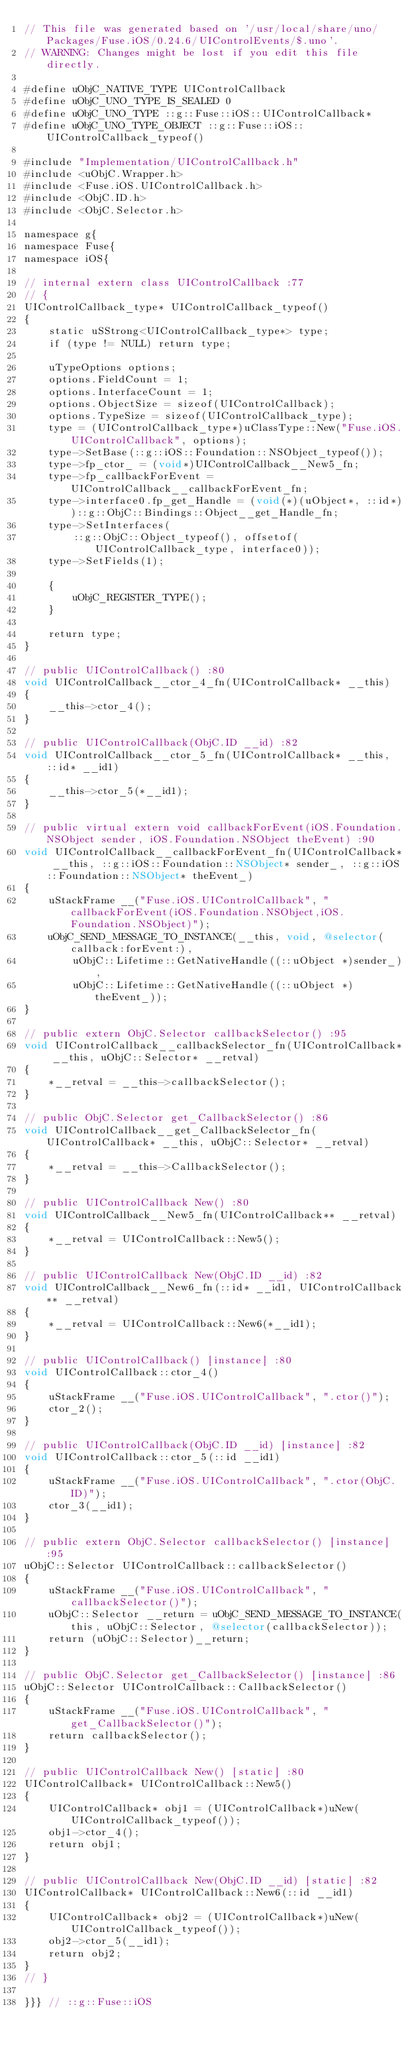<code> <loc_0><loc_0><loc_500><loc_500><_ObjectiveC_>// This file was generated based on '/usr/local/share/uno/Packages/Fuse.iOS/0.24.6/UIControlEvents/$.uno'.
// WARNING: Changes might be lost if you edit this file directly.

#define uObjC_NATIVE_TYPE UIControlCallback
#define uObjC_UNO_TYPE_IS_SEALED 0
#define uObjC_UNO_TYPE ::g::Fuse::iOS::UIControlCallback*
#define uObjC_UNO_TYPE_OBJECT ::g::Fuse::iOS::UIControlCallback_typeof()

#include "Implementation/UIControlCallback.h"
#include <uObjC.Wrapper.h>
#include <Fuse.iOS.UIControlCallback.h>
#include <ObjC.ID.h>
#include <ObjC.Selector.h>

namespace g{
namespace Fuse{
namespace iOS{

// internal extern class UIControlCallback :77
// {
UIControlCallback_type* UIControlCallback_typeof()
{
    static uSStrong<UIControlCallback_type*> type;
    if (type != NULL) return type;

    uTypeOptions options;
    options.FieldCount = 1;
    options.InterfaceCount = 1;
    options.ObjectSize = sizeof(UIControlCallback);
    options.TypeSize = sizeof(UIControlCallback_type);
    type = (UIControlCallback_type*)uClassType::New("Fuse.iOS.UIControlCallback", options);
    type->SetBase(::g::iOS::Foundation::NSObject_typeof());
    type->fp_ctor_ = (void*)UIControlCallback__New5_fn;
    type->fp_callbackForEvent = UIControlCallback__callbackForEvent_fn;
    type->interface0.fp_get_Handle = (void(*)(uObject*, ::id*))::g::ObjC::Bindings::Object__get_Handle_fn;
    type->SetInterfaces(
        ::g::ObjC::Object_typeof(), offsetof(UIControlCallback_type, interface0));
    type->SetFields(1);

    {
        uObjC_REGISTER_TYPE();
    }

    return type;
}

// public UIControlCallback() :80
void UIControlCallback__ctor_4_fn(UIControlCallback* __this)
{
    __this->ctor_4();
}

// public UIControlCallback(ObjC.ID __id) :82
void UIControlCallback__ctor_5_fn(UIControlCallback* __this, ::id* __id1)
{
    __this->ctor_5(*__id1);
}

// public virtual extern void callbackForEvent(iOS.Foundation.NSObject sender, iOS.Foundation.NSObject theEvent) :90
void UIControlCallback__callbackForEvent_fn(UIControlCallback* __this, ::g::iOS::Foundation::NSObject* sender_, ::g::iOS::Foundation::NSObject* theEvent_)
{
    uStackFrame __("Fuse.iOS.UIControlCallback", "callbackForEvent(iOS.Foundation.NSObject,iOS.Foundation.NSObject)");
    uObjC_SEND_MESSAGE_TO_INSTANCE(__this, void, @selector(callback:forEvent:),
        uObjC::Lifetime::GetNativeHandle((::uObject *)sender_),
        uObjC::Lifetime::GetNativeHandle((::uObject *)theEvent_));
}

// public extern ObjC.Selector callbackSelector() :95
void UIControlCallback__callbackSelector_fn(UIControlCallback* __this, uObjC::Selector* __retval)
{
    *__retval = __this->callbackSelector();
}

// public ObjC.Selector get_CallbackSelector() :86
void UIControlCallback__get_CallbackSelector_fn(UIControlCallback* __this, uObjC::Selector* __retval)
{
    *__retval = __this->CallbackSelector();
}

// public UIControlCallback New() :80
void UIControlCallback__New5_fn(UIControlCallback** __retval)
{
    *__retval = UIControlCallback::New5();
}

// public UIControlCallback New(ObjC.ID __id) :82
void UIControlCallback__New6_fn(::id* __id1, UIControlCallback** __retval)
{
    *__retval = UIControlCallback::New6(*__id1);
}

// public UIControlCallback() [instance] :80
void UIControlCallback::ctor_4()
{
    uStackFrame __("Fuse.iOS.UIControlCallback", ".ctor()");
    ctor_2();
}

// public UIControlCallback(ObjC.ID __id) [instance] :82
void UIControlCallback::ctor_5(::id __id1)
{
    uStackFrame __("Fuse.iOS.UIControlCallback", ".ctor(ObjC.ID)");
    ctor_3(__id1);
}

// public extern ObjC.Selector callbackSelector() [instance] :95
uObjC::Selector UIControlCallback::callbackSelector()
{
    uStackFrame __("Fuse.iOS.UIControlCallback", "callbackSelector()");
    uObjC::Selector __return = uObjC_SEND_MESSAGE_TO_INSTANCE(this, uObjC::Selector, @selector(callbackSelector));
    return (uObjC::Selector)__return;
}

// public ObjC.Selector get_CallbackSelector() [instance] :86
uObjC::Selector UIControlCallback::CallbackSelector()
{
    uStackFrame __("Fuse.iOS.UIControlCallback", "get_CallbackSelector()");
    return callbackSelector();
}

// public UIControlCallback New() [static] :80
UIControlCallback* UIControlCallback::New5()
{
    UIControlCallback* obj1 = (UIControlCallback*)uNew(UIControlCallback_typeof());
    obj1->ctor_4();
    return obj1;
}

// public UIControlCallback New(ObjC.ID __id) [static] :82
UIControlCallback* UIControlCallback::New6(::id __id1)
{
    UIControlCallback* obj2 = (UIControlCallback*)uNew(UIControlCallback_typeof());
    obj2->ctor_5(__id1);
    return obj2;
}
// }

}}} // ::g::Fuse::iOS
</code> 